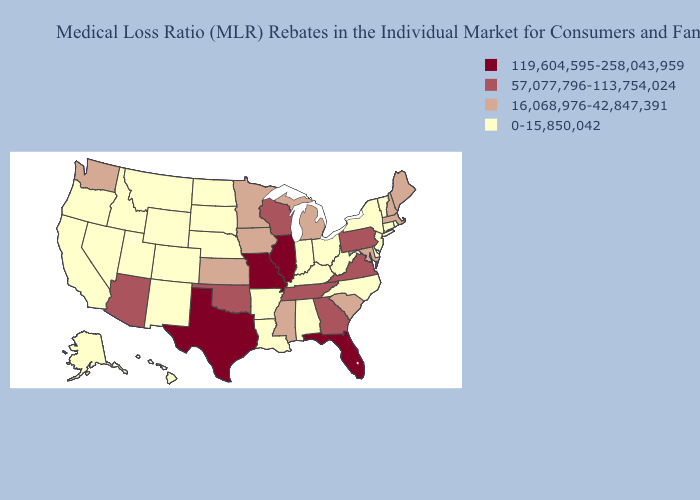Among the states that border Kansas , does Colorado have the highest value?
Be succinct. No. Name the states that have a value in the range 119,604,595-258,043,959?
Quick response, please. Florida, Illinois, Missouri, Texas. Among the states that border Nebraska , which have the lowest value?
Be succinct. Colorado, South Dakota, Wyoming. What is the lowest value in the USA?
Give a very brief answer. 0-15,850,042. Does Delaware have the same value as Maine?
Concise answer only. No. What is the highest value in the USA?
Concise answer only. 119,604,595-258,043,959. Which states have the lowest value in the USA?
Give a very brief answer. Alabama, Alaska, Arkansas, California, Colorado, Connecticut, Delaware, Hawaii, Idaho, Indiana, Kentucky, Louisiana, Montana, Nebraska, Nevada, New Jersey, New Mexico, New York, North Carolina, North Dakota, Ohio, Oregon, Rhode Island, South Dakota, Utah, Vermont, West Virginia, Wyoming. What is the value of Nebraska?
Write a very short answer. 0-15,850,042. What is the highest value in the USA?
Keep it brief. 119,604,595-258,043,959. Which states hav the highest value in the South?
Give a very brief answer. Florida, Texas. What is the lowest value in the USA?
Keep it brief. 0-15,850,042. What is the lowest value in the USA?
Short answer required. 0-15,850,042. Name the states that have a value in the range 119,604,595-258,043,959?
Give a very brief answer. Florida, Illinois, Missouri, Texas. Which states have the lowest value in the USA?
Short answer required. Alabama, Alaska, Arkansas, California, Colorado, Connecticut, Delaware, Hawaii, Idaho, Indiana, Kentucky, Louisiana, Montana, Nebraska, Nevada, New Jersey, New Mexico, New York, North Carolina, North Dakota, Ohio, Oregon, Rhode Island, South Dakota, Utah, Vermont, West Virginia, Wyoming. Name the states that have a value in the range 57,077,796-113,754,024?
Answer briefly. Arizona, Georgia, Oklahoma, Pennsylvania, Tennessee, Virginia, Wisconsin. 